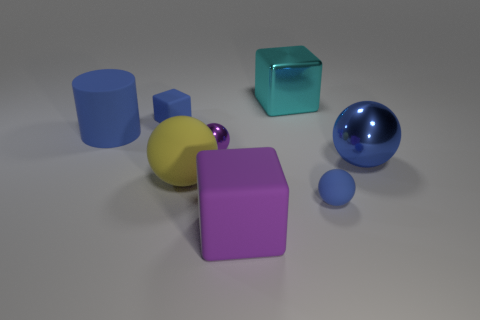Subtract all blue balls. How many were subtracted if there are1blue balls left? 1 Subtract all tiny blue matte spheres. How many spheres are left? 3 Subtract all blue spheres. How many spheres are left? 2 Add 2 cyan metallic cubes. How many objects exist? 10 Subtract 3 spheres. How many spheres are left? 1 Subtract all large cyan metal cylinders. Subtract all cyan shiny things. How many objects are left? 7 Add 4 big yellow objects. How many big yellow objects are left? 5 Add 7 large blue matte things. How many large blue matte things exist? 8 Subtract 0 gray blocks. How many objects are left? 8 Subtract all cylinders. How many objects are left? 7 